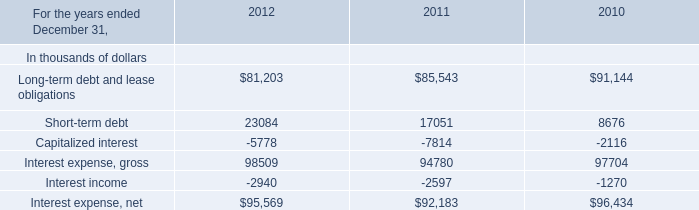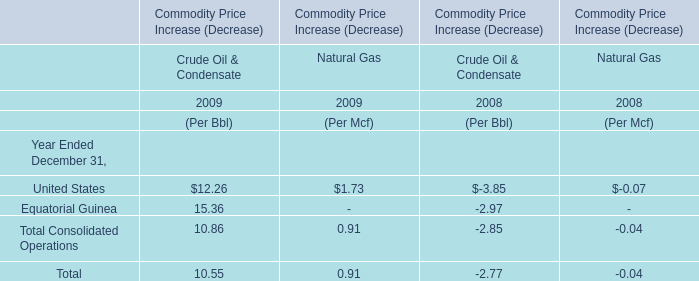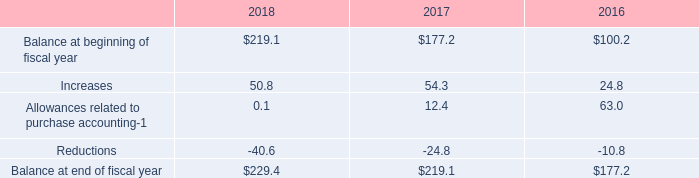What is the percentage of all Natural Gas that are positive to the total amount, in 2009 for Commodity Price Increase (Decrease)？ 
Computations: ((1.73 + 0.91) + 0.91)
Answer: 3.55. 